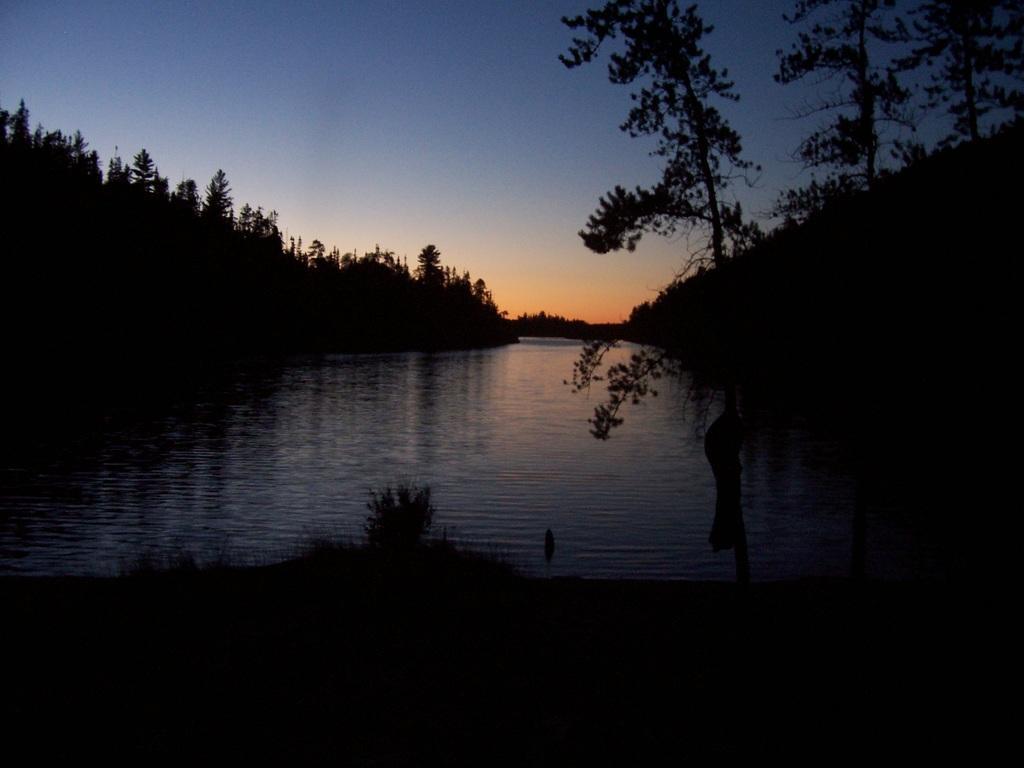Can you describe this image briefly? Here we can see water. Beside this water there are trees. Sky is in blue color. 